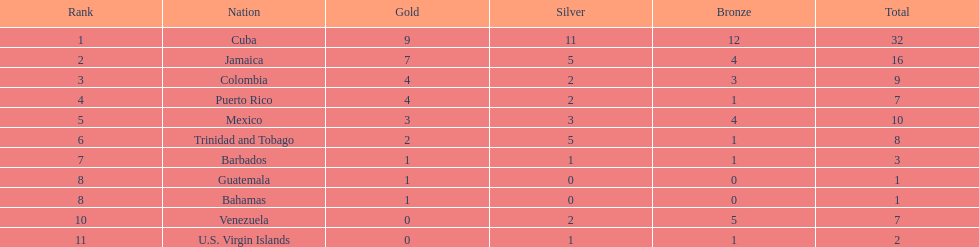What is the total number of gold medals awarded between these 11 countries? 32. 